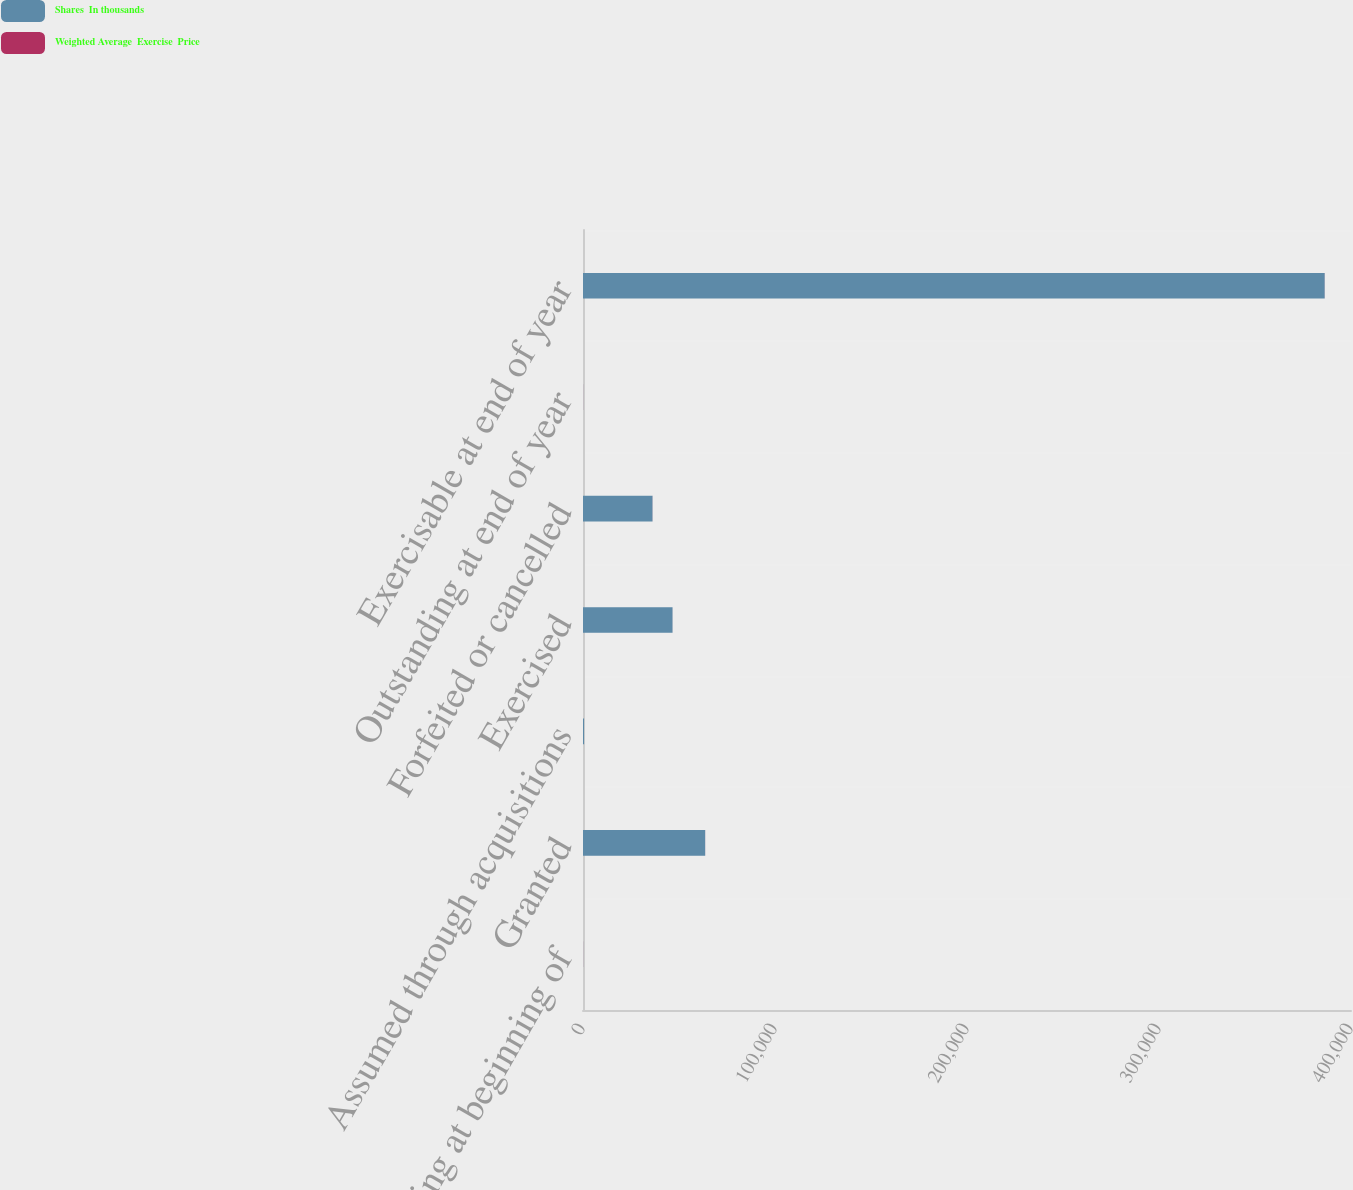<chart> <loc_0><loc_0><loc_500><loc_500><stacked_bar_chart><ecel><fcel>Outstanding at beginning of<fcel>Granted<fcel>Assumed through acquisitions<fcel>Exercised<fcel>Forfeited or cancelled<fcel>Outstanding at end of year<fcel>Exercisable at end of year<nl><fcel>Shares  In thousands<fcel>34<fcel>63635<fcel>558<fcel>46628<fcel>36200<fcel>34<fcel>386303<nl><fcel>Weighted Average  Exercise  Price<fcel>30<fcel>22<fcel>1<fcel>17<fcel>35<fcel>30<fcel>33<nl></chart> 